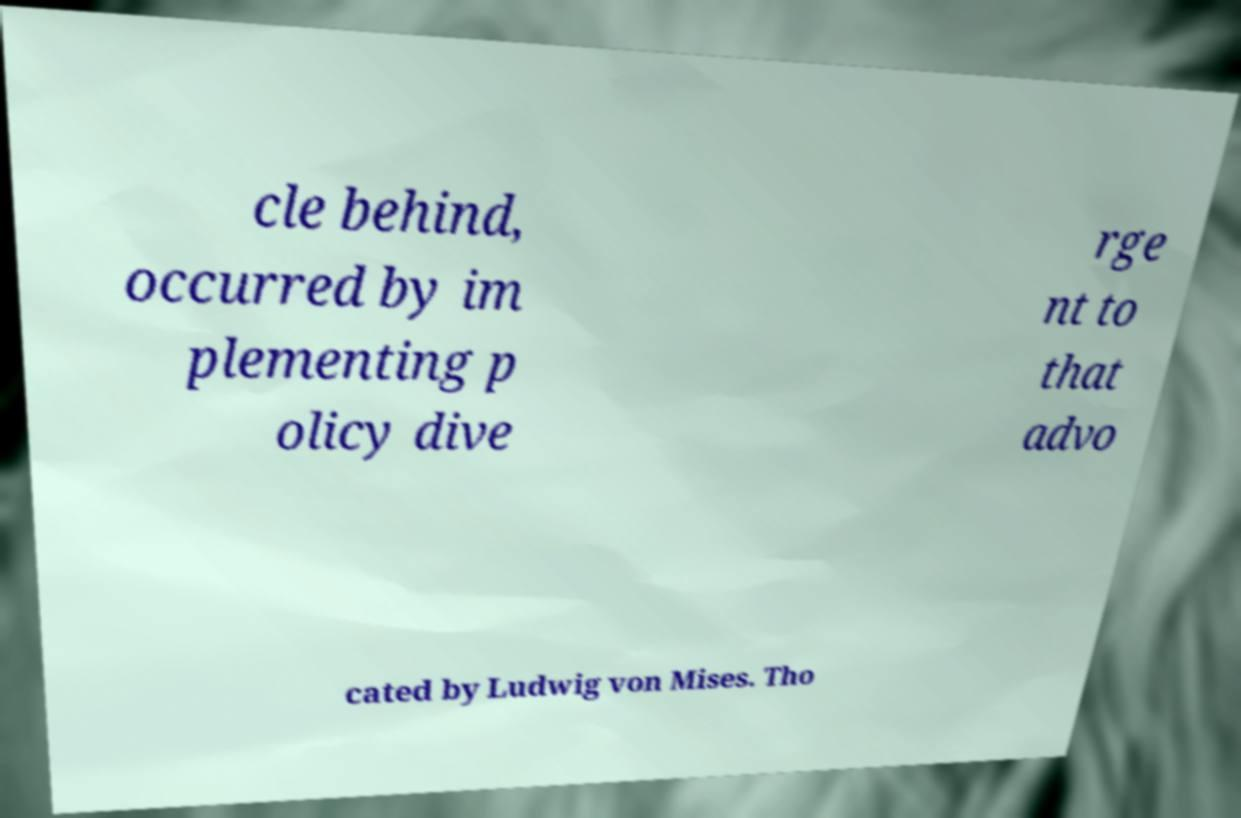Can you read and provide the text displayed in the image?This photo seems to have some interesting text. Can you extract and type it out for me? cle behind, occurred by im plementing p olicy dive rge nt to that advo cated by Ludwig von Mises. Tho 